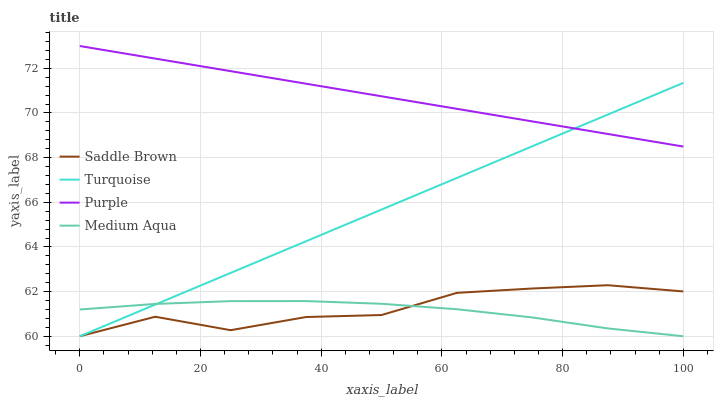Does Medium Aqua have the minimum area under the curve?
Answer yes or no. Yes. Does Purple have the maximum area under the curve?
Answer yes or no. Yes. Does Turquoise have the minimum area under the curve?
Answer yes or no. No. Does Turquoise have the maximum area under the curve?
Answer yes or no. No. Is Turquoise the smoothest?
Answer yes or no. Yes. Is Saddle Brown the roughest?
Answer yes or no. Yes. Is Medium Aqua the smoothest?
Answer yes or no. No. Is Medium Aqua the roughest?
Answer yes or no. No. Does Turquoise have the lowest value?
Answer yes or no. Yes. Does Purple have the highest value?
Answer yes or no. Yes. Does Turquoise have the highest value?
Answer yes or no. No. Is Medium Aqua less than Purple?
Answer yes or no. Yes. Is Purple greater than Medium Aqua?
Answer yes or no. Yes. Does Medium Aqua intersect Turquoise?
Answer yes or no. Yes. Is Medium Aqua less than Turquoise?
Answer yes or no. No. Is Medium Aqua greater than Turquoise?
Answer yes or no. No. Does Medium Aqua intersect Purple?
Answer yes or no. No. 